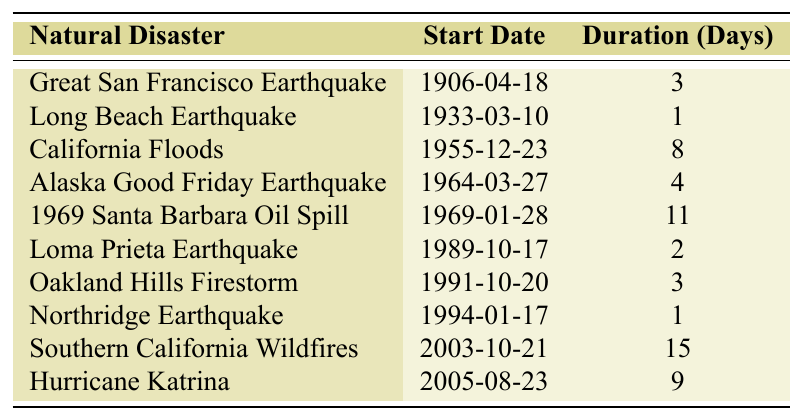What was the duration of the Great San Francisco Earthquake? The table shows that the Great San Francisco Earthquake lasted for 3 days.
Answer: 3 days Which natural disaster occurred first? Looking at the start dates, the Great San Francisco Earthquake on 1906-04-18 is the earliest event.
Answer: Great San Francisco Earthquake What is the average duration of the listed natural disasters? To find the average, sum the durations (3 + 1 + 8 + 4 + 11 + 2 + 3 + 1 + 15 + 9 = 57 days) and divide by the number of disasters (10). Therefore, 57 / 10 = 5.7 days.
Answer: 5.7 days Was Hurricane Katrina longer than the California Floods? Hurricane Katrina lasted for 9 days and the California Floods lasted for 8 days; therefore, Hurricane Katrina was indeed longer.
Answer: Yes How many natural disasters had a duration of more than 10 days? From the table, only the 1969 Santa Barbara Oil Spill lasted for 11 days. Hence, there is only one disaster that meets this criterion.
Answer: 1 Which earthquake had the shortest duration? The Northridge Earthquake had a duration of just 1 day, which is the shortest among the listed events.
Answer: Northridge Earthquake What is the total duration of all the natural disasters listed? To find the total duration, sum all the days: 3 + 1 + 8 + 4 + 11 + 2 + 3 + 1 + 15 + 9 = 57 days.
Answer: 57 days How many natural disasters occurred in the 1990s? There are three events from the 1990s: Loma Prieta Earthquake (1989), Oakland Hills Firestorm (1991), and Northridge Earthquake (1994), making a total of three.
Answer: 3 Is the duration of the Southern California Wildfires greater than the combined duration of the Long Beach Earthquake and the Northridge Earthquake? The Southern California Wildfires lasted for 15 days, while the Long Beach Earthquake and the Northridge Earthquake lasted for a combined total of 1 + 1 = 2 days. Therefore, 15 days is greater than 2 days.
Answer: Yes If we compare the durations of California Floods and the Alaska Good Friday Earthquake, which lasted longer? The California Floods lasted for 8 days while the Alaska Good Friday Earthquake lasted for 4 days. 8 days is longer than 4 days.
Answer: California Floods 